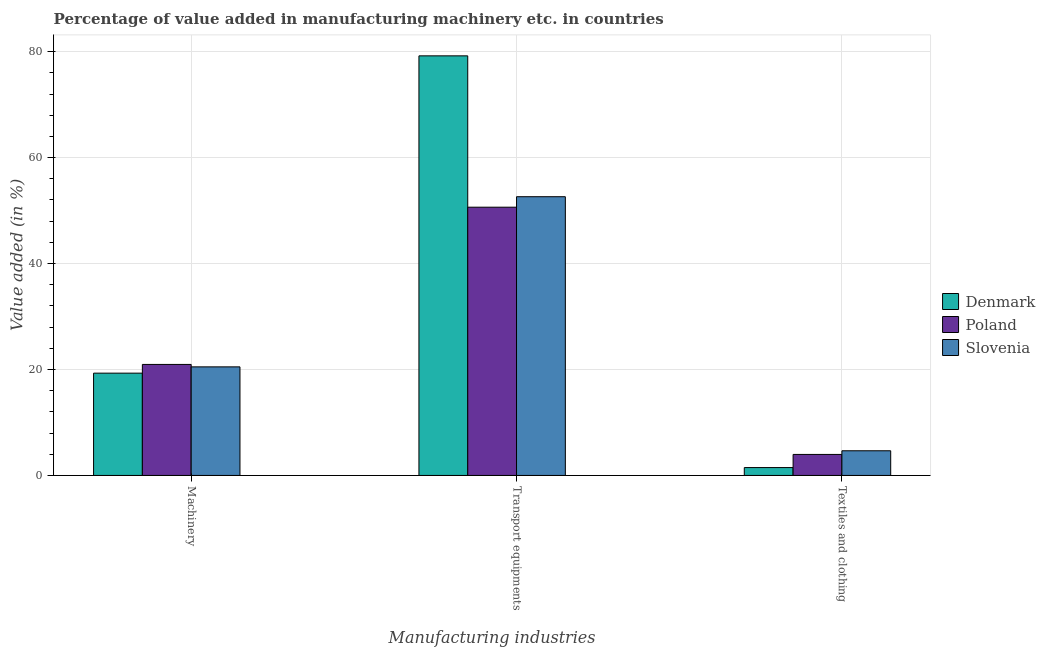How many different coloured bars are there?
Your response must be concise. 3. Are the number of bars on each tick of the X-axis equal?
Provide a short and direct response. Yes. What is the label of the 1st group of bars from the left?
Offer a very short reply. Machinery. What is the value added in manufacturing machinery in Denmark?
Make the answer very short. 19.31. Across all countries, what is the maximum value added in manufacturing machinery?
Your response must be concise. 20.95. Across all countries, what is the minimum value added in manufacturing textile and clothing?
Offer a terse response. 1.49. In which country was the value added in manufacturing transport equipments maximum?
Your answer should be compact. Denmark. In which country was the value added in manufacturing transport equipments minimum?
Make the answer very short. Poland. What is the total value added in manufacturing transport equipments in the graph?
Ensure brevity in your answer.  182.46. What is the difference between the value added in manufacturing machinery in Denmark and that in Poland?
Keep it short and to the point. -1.65. What is the difference between the value added in manufacturing transport equipments in Poland and the value added in manufacturing machinery in Slovenia?
Keep it short and to the point. 30.14. What is the average value added in manufacturing transport equipments per country?
Give a very brief answer. 60.82. What is the difference between the value added in manufacturing machinery and value added in manufacturing textile and clothing in Denmark?
Give a very brief answer. 17.82. What is the ratio of the value added in manufacturing textile and clothing in Slovenia to that in Denmark?
Your answer should be very brief. 3.14. Is the value added in manufacturing textile and clothing in Slovenia less than that in Poland?
Offer a very short reply. No. What is the difference between the highest and the second highest value added in manufacturing machinery?
Offer a terse response. 0.46. What is the difference between the highest and the lowest value added in manufacturing textile and clothing?
Provide a short and direct response. 3.17. Is the sum of the value added in manufacturing machinery in Slovenia and Denmark greater than the maximum value added in manufacturing textile and clothing across all countries?
Ensure brevity in your answer.  Yes. What does the 2nd bar from the left in Transport equipments represents?
Provide a short and direct response. Poland. What does the 1st bar from the right in Textiles and clothing represents?
Offer a terse response. Slovenia. Are all the bars in the graph horizontal?
Ensure brevity in your answer.  No. How many countries are there in the graph?
Provide a succinct answer. 3. Are the values on the major ticks of Y-axis written in scientific E-notation?
Provide a succinct answer. No. Does the graph contain any zero values?
Provide a succinct answer. No. Does the graph contain grids?
Offer a terse response. Yes. Where does the legend appear in the graph?
Your response must be concise. Center right. What is the title of the graph?
Offer a very short reply. Percentage of value added in manufacturing machinery etc. in countries. What is the label or title of the X-axis?
Provide a short and direct response. Manufacturing industries. What is the label or title of the Y-axis?
Your response must be concise. Value added (in %). What is the Value added (in %) of Denmark in Machinery?
Your answer should be compact. 19.31. What is the Value added (in %) in Poland in Machinery?
Offer a terse response. 20.95. What is the Value added (in %) in Slovenia in Machinery?
Offer a terse response. 20.5. What is the Value added (in %) of Denmark in Transport equipments?
Your answer should be compact. 79.21. What is the Value added (in %) of Poland in Transport equipments?
Offer a terse response. 50.64. What is the Value added (in %) in Slovenia in Transport equipments?
Offer a very short reply. 52.62. What is the Value added (in %) of Denmark in Textiles and clothing?
Offer a very short reply. 1.49. What is the Value added (in %) of Poland in Textiles and clothing?
Ensure brevity in your answer.  3.97. What is the Value added (in %) in Slovenia in Textiles and clothing?
Keep it short and to the point. 4.66. Across all Manufacturing industries, what is the maximum Value added (in %) in Denmark?
Provide a short and direct response. 79.21. Across all Manufacturing industries, what is the maximum Value added (in %) of Poland?
Your answer should be very brief. 50.64. Across all Manufacturing industries, what is the maximum Value added (in %) in Slovenia?
Your answer should be very brief. 52.62. Across all Manufacturing industries, what is the minimum Value added (in %) of Denmark?
Your answer should be compact. 1.49. Across all Manufacturing industries, what is the minimum Value added (in %) in Poland?
Make the answer very short. 3.97. Across all Manufacturing industries, what is the minimum Value added (in %) in Slovenia?
Your answer should be very brief. 4.66. What is the total Value added (in %) in Denmark in the graph?
Make the answer very short. 100. What is the total Value added (in %) of Poland in the graph?
Ensure brevity in your answer.  75.56. What is the total Value added (in %) of Slovenia in the graph?
Your answer should be very brief. 77.77. What is the difference between the Value added (in %) of Denmark in Machinery and that in Transport equipments?
Ensure brevity in your answer.  -59.9. What is the difference between the Value added (in %) of Poland in Machinery and that in Transport equipments?
Offer a very short reply. -29.68. What is the difference between the Value added (in %) of Slovenia in Machinery and that in Transport equipments?
Ensure brevity in your answer.  -32.12. What is the difference between the Value added (in %) in Denmark in Machinery and that in Textiles and clothing?
Offer a very short reply. 17.82. What is the difference between the Value added (in %) in Poland in Machinery and that in Textiles and clothing?
Keep it short and to the point. 16.99. What is the difference between the Value added (in %) of Slovenia in Machinery and that in Textiles and clothing?
Your answer should be very brief. 15.84. What is the difference between the Value added (in %) in Denmark in Transport equipments and that in Textiles and clothing?
Keep it short and to the point. 77.72. What is the difference between the Value added (in %) of Poland in Transport equipments and that in Textiles and clothing?
Make the answer very short. 46.67. What is the difference between the Value added (in %) of Slovenia in Transport equipments and that in Textiles and clothing?
Ensure brevity in your answer.  47.96. What is the difference between the Value added (in %) in Denmark in Machinery and the Value added (in %) in Poland in Transport equipments?
Offer a very short reply. -31.33. What is the difference between the Value added (in %) of Denmark in Machinery and the Value added (in %) of Slovenia in Transport equipments?
Your response must be concise. -33.31. What is the difference between the Value added (in %) of Poland in Machinery and the Value added (in %) of Slovenia in Transport equipments?
Offer a terse response. -31.66. What is the difference between the Value added (in %) of Denmark in Machinery and the Value added (in %) of Poland in Textiles and clothing?
Your answer should be compact. 15.34. What is the difference between the Value added (in %) in Denmark in Machinery and the Value added (in %) in Slovenia in Textiles and clothing?
Your response must be concise. 14.65. What is the difference between the Value added (in %) in Poland in Machinery and the Value added (in %) in Slovenia in Textiles and clothing?
Provide a succinct answer. 16.3. What is the difference between the Value added (in %) in Denmark in Transport equipments and the Value added (in %) in Poland in Textiles and clothing?
Your answer should be compact. 75.24. What is the difference between the Value added (in %) of Denmark in Transport equipments and the Value added (in %) of Slovenia in Textiles and clothing?
Your answer should be compact. 74.55. What is the difference between the Value added (in %) in Poland in Transport equipments and the Value added (in %) in Slovenia in Textiles and clothing?
Ensure brevity in your answer.  45.98. What is the average Value added (in %) of Denmark per Manufacturing industries?
Make the answer very short. 33.33. What is the average Value added (in %) in Poland per Manufacturing industries?
Keep it short and to the point. 25.19. What is the average Value added (in %) of Slovenia per Manufacturing industries?
Provide a succinct answer. 25.92. What is the difference between the Value added (in %) of Denmark and Value added (in %) of Poland in Machinery?
Your response must be concise. -1.65. What is the difference between the Value added (in %) in Denmark and Value added (in %) in Slovenia in Machinery?
Your answer should be very brief. -1.19. What is the difference between the Value added (in %) in Poland and Value added (in %) in Slovenia in Machinery?
Give a very brief answer. 0.46. What is the difference between the Value added (in %) in Denmark and Value added (in %) in Poland in Transport equipments?
Give a very brief answer. 28.57. What is the difference between the Value added (in %) in Denmark and Value added (in %) in Slovenia in Transport equipments?
Offer a very short reply. 26.59. What is the difference between the Value added (in %) of Poland and Value added (in %) of Slovenia in Transport equipments?
Offer a terse response. -1.98. What is the difference between the Value added (in %) of Denmark and Value added (in %) of Poland in Textiles and clothing?
Ensure brevity in your answer.  -2.48. What is the difference between the Value added (in %) of Denmark and Value added (in %) of Slovenia in Textiles and clothing?
Offer a very short reply. -3.17. What is the difference between the Value added (in %) in Poland and Value added (in %) in Slovenia in Textiles and clothing?
Your response must be concise. -0.69. What is the ratio of the Value added (in %) of Denmark in Machinery to that in Transport equipments?
Offer a terse response. 0.24. What is the ratio of the Value added (in %) of Poland in Machinery to that in Transport equipments?
Your answer should be very brief. 0.41. What is the ratio of the Value added (in %) of Slovenia in Machinery to that in Transport equipments?
Keep it short and to the point. 0.39. What is the ratio of the Value added (in %) of Denmark in Machinery to that in Textiles and clothing?
Give a very brief answer. 13. What is the ratio of the Value added (in %) in Poland in Machinery to that in Textiles and clothing?
Offer a terse response. 5.28. What is the ratio of the Value added (in %) in Slovenia in Machinery to that in Textiles and clothing?
Make the answer very short. 4.4. What is the ratio of the Value added (in %) of Denmark in Transport equipments to that in Textiles and clothing?
Provide a short and direct response. 53.33. What is the ratio of the Value added (in %) in Poland in Transport equipments to that in Textiles and clothing?
Offer a very short reply. 12.76. What is the ratio of the Value added (in %) of Slovenia in Transport equipments to that in Textiles and clothing?
Offer a very short reply. 11.3. What is the difference between the highest and the second highest Value added (in %) of Denmark?
Keep it short and to the point. 59.9. What is the difference between the highest and the second highest Value added (in %) in Poland?
Your response must be concise. 29.68. What is the difference between the highest and the second highest Value added (in %) in Slovenia?
Give a very brief answer. 32.12. What is the difference between the highest and the lowest Value added (in %) of Denmark?
Offer a very short reply. 77.72. What is the difference between the highest and the lowest Value added (in %) of Poland?
Provide a succinct answer. 46.67. What is the difference between the highest and the lowest Value added (in %) of Slovenia?
Your response must be concise. 47.96. 